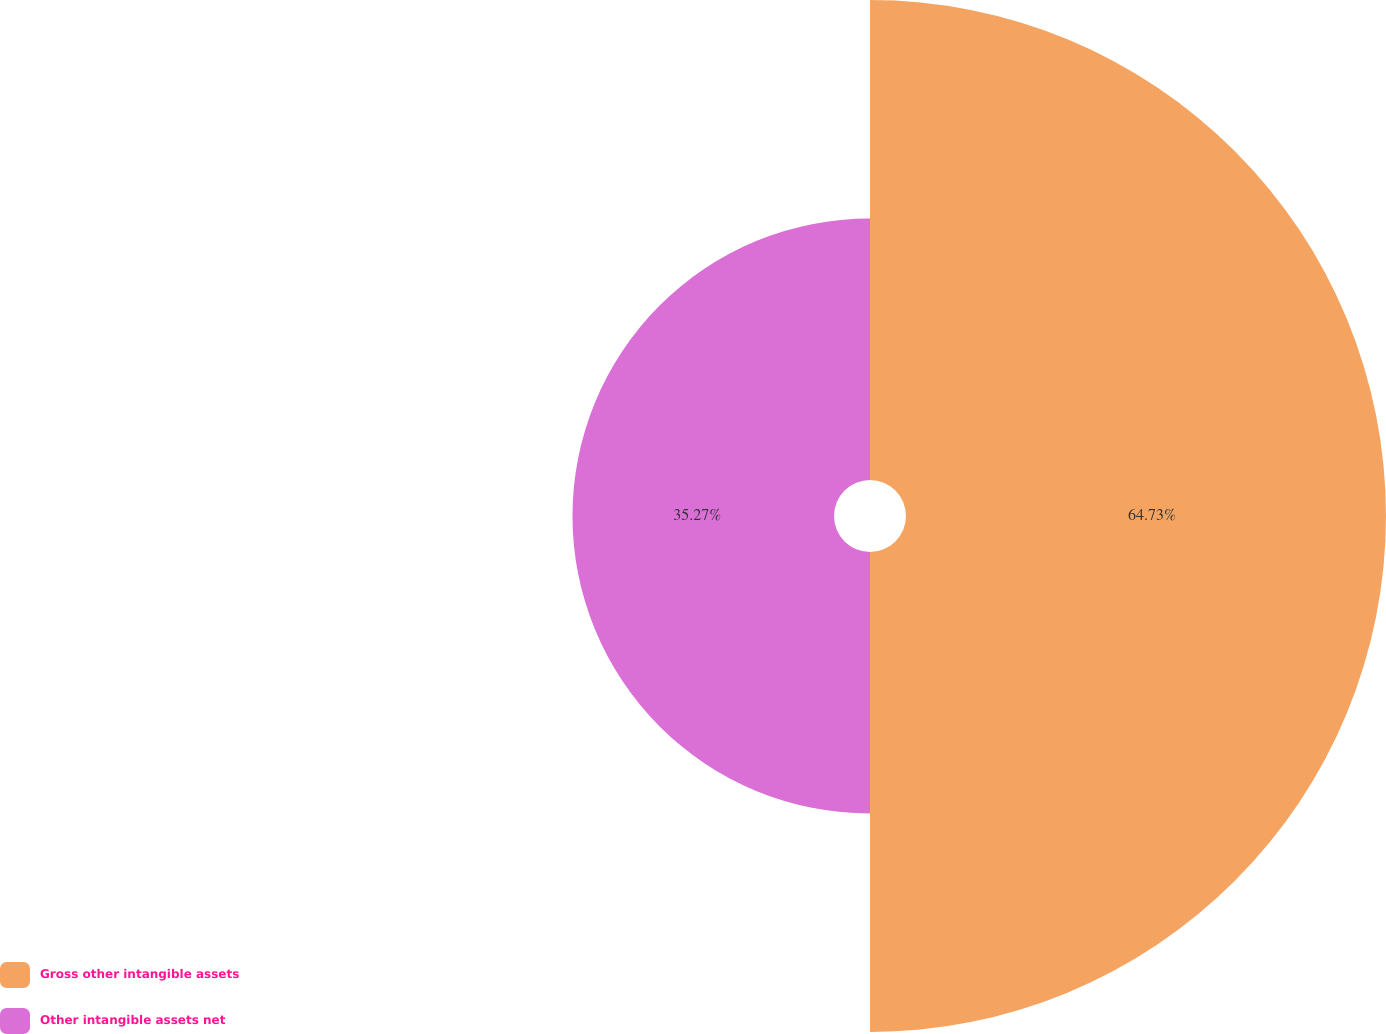<chart> <loc_0><loc_0><loc_500><loc_500><pie_chart><fcel>Gross other intangible assets<fcel>Other intangible assets net<nl><fcel>64.73%<fcel>35.27%<nl></chart> 